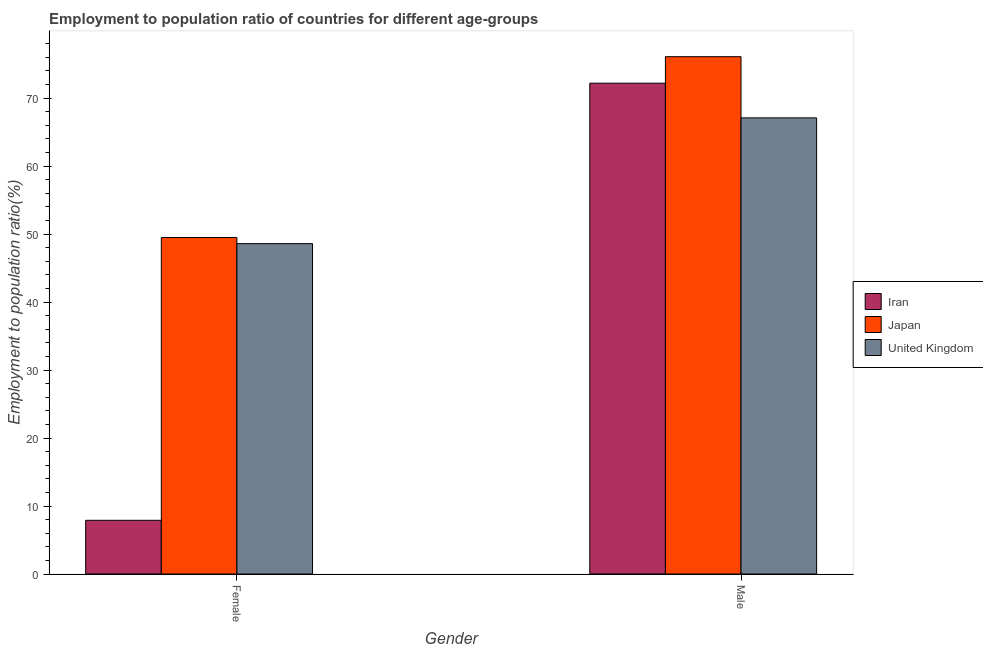How many groups of bars are there?
Ensure brevity in your answer.  2. How many bars are there on the 2nd tick from the left?
Provide a succinct answer. 3. What is the label of the 2nd group of bars from the left?
Offer a very short reply. Male. What is the employment to population ratio(female) in United Kingdom?
Offer a terse response. 48.6. Across all countries, what is the maximum employment to population ratio(male)?
Ensure brevity in your answer.  76.1. Across all countries, what is the minimum employment to population ratio(male)?
Keep it short and to the point. 67.1. In which country was the employment to population ratio(male) minimum?
Your answer should be compact. United Kingdom. What is the total employment to population ratio(female) in the graph?
Keep it short and to the point. 106. What is the difference between the employment to population ratio(female) in Japan and that in United Kingdom?
Your answer should be compact. 0.9. What is the difference between the employment to population ratio(female) in Japan and the employment to population ratio(male) in United Kingdom?
Your answer should be very brief. -17.6. What is the average employment to population ratio(female) per country?
Give a very brief answer. 35.33. What is the difference between the employment to population ratio(male) and employment to population ratio(female) in United Kingdom?
Give a very brief answer. 18.5. In how many countries, is the employment to population ratio(female) greater than 20 %?
Keep it short and to the point. 2. What is the ratio of the employment to population ratio(male) in Japan to that in Iran?
Your answer should be compact. 1.05. Is the employment to population ratio(male) in Japan less than that in United Kingdom?
Offer a terse response. No. In how many countries, is the employment to population ratio(female) greater than the average employment to population ratio(female) taken over all countries?
Ensure brevity in your answer.  2. What does the 1st bar from the left in Male represents?
Make the answer very short. Iran. What does the 1st bar from the right in Male represents?
Give a very brief answer. United Kingdom. How many bars are there?
Provide a short and direct response. 6. What is the difference between two consecutive major ticks on the Y-axis?
Give a very brief answer. 10. Are the values on the major ticks of Y-axis written in scientific E-notation?
Offer a terse response. No. Where does the legend appear in the graph?
Provide a short and direct response. Center right. How many legend labels are there?
Provide a short and direct response. 3. What is the title of the graph?
Keep it short and to the point. Employment to population ratio of countries for different age-groups. Does "Libya" appear as one of the legend labels in the graph?
Your response must be concise. No. What is the Employment to population ratio(%) in Iran in Female?
Your response must be concise. 7.9. What is the Employment to population ratio(%) in Japan in Female?
Offer a terse response. 49.5. What is the Employment to population ratio(%) of United Kingdom in Female?
Keep it short and to the point. 48.6. What is the Employment to population ratio(%) in Iran in Male?
Ensure brevity in your answer.  72.2. What is the Employment to population ratio(%) in Japan in Male?
Offer a terse response. 76.1. What is the Employment to population ratio(%) in United Kingdom in Male?
Ensure brevity in your answer.  67.1. Across all Gender, what is the maximum Employment to population ratio(%) in Iran?
Your response must be concise. 72.2. Across all Gender, what is the maximum Employment to population ratio(%) of Japan?
Your answer should be compact. 76.1. Across all Gender, what is the maximum Employment to population ratio(%) of United Kingdom?
Make the answer very short. 67.1. Across all Gender, what is the minimum Employment to population ratio(%) of Iran?
Your answer should be compact. 7.9. Across all Gender, what is the minimum Employment to population ratio(%) in Japan?
Offer a terse response. 49.5. Across all Gender, what is the minimum Employment to population ratio(%) of United Kingdom?
Offer a very short reply. 48.6. What is the total Employment to population ratio(%) in Iran in the graph?
Your response must be concise. 80.1. What is the total Employment to population ratio(%) in Japan in the graph?
Your answer should be compact. 125.6. What is the total Employment to population ratio(%) of United Kingdom in the graph?
Provide a short and direct response. 115.7. What is the difference between the Employment to population ratio(%) in Iran in Female and that in Male?
Your response must be concise. -64.3. What is the difference between the Employment to population ratio(%) of Japan in Female and that in Male?
Your response must be concise. -26.6. What is the difference between the Employment to population ratio(%) of United Kingdom in Female and that in Male?
Your answer should be very brief. -18.5. What is the difference between the Employment to population ratio(%) in Iran in Female and the Employment to population ratio(%) in Japan in Male?
Give a very brief answer. -68.2. What is the difference between the Employment to population ratio(%) in Iran in Female and the Employment to population ratio(%) in United Kingdom in Male?
Your answer should be compact. -59.2. What is the difference between the Employment to population ratio(%) of Japan in Female and the Employment to population ratio(%) of United Kingdom in Male?
Your answer should be very brief. -17.6. What is the average Employment to population ratio(%) in Iran per Gender?
Your response must be concise. 40.05. What is the average Employment to population ratio(%) of Japan per Gender?
Make the answer very short. 62.8. What is the average Employment to population ratio(%) of United Kingdom per Gender?
Provide a short and direct response. 57.85. What is the difference between the Employment to population ratio(%) of Iran and Employment to population ratio(%) of Japan in Female?
Provide a short and direct response. -41.6. What is the difference between the Employment to population ratio(%) in Iran and Employment to population ratio(%) in United Kingdom in Female?
Ensure brevity in your answer.  -40.7. What is the difference between the Employment to population ratio(%) of Japan and Employment to population ratio(%) of United Kingdom in Female?
Your answer should be compact. 0.9. What is the difference between the Employment to population ratio(%) of Japan and Employment to population ratio(%) of United Kingdom in Male?
Provide a short and direct response. 9. What is the ratio of the Employment to population ratio(%) in Iran in Female to that in Male?
Your answer should be very brief. 0.11. What is the ratio of the Employment to population ratio(%) of Japan in Female to that in Male?
Offer a terse response. 0.65. What is the ratio of the Employment to population ratio(%) in United Kingdom in Female to that in Male?
Offer a very short reply. 0.72. What is the difference between the highest and the second highest Employment to population ratio(%) of Iran?
Keep it short and to the point. 64.3. What is the difference between the highest and the second highest Employment to population ratio(%) in Japan?
Your response must be concise. 26.6. What is the difference between the highest and the second highest Employment to population ratio(%) in United Kingdom?
Your answer should be very brief. 18.5. What is the difference between the highest and the lowest Employment to population ratio(%) in Iran?
Offer a terse response. 64.3. What is the difference between the highest and the lowest Employment to population ratio(%) in Japan?
Make the answer very short. 26.6. What is the difference between the highest and the lowest Employment to population ratio(%) in United Kingdom?
Ensure brevity in your answer.  18.5. 